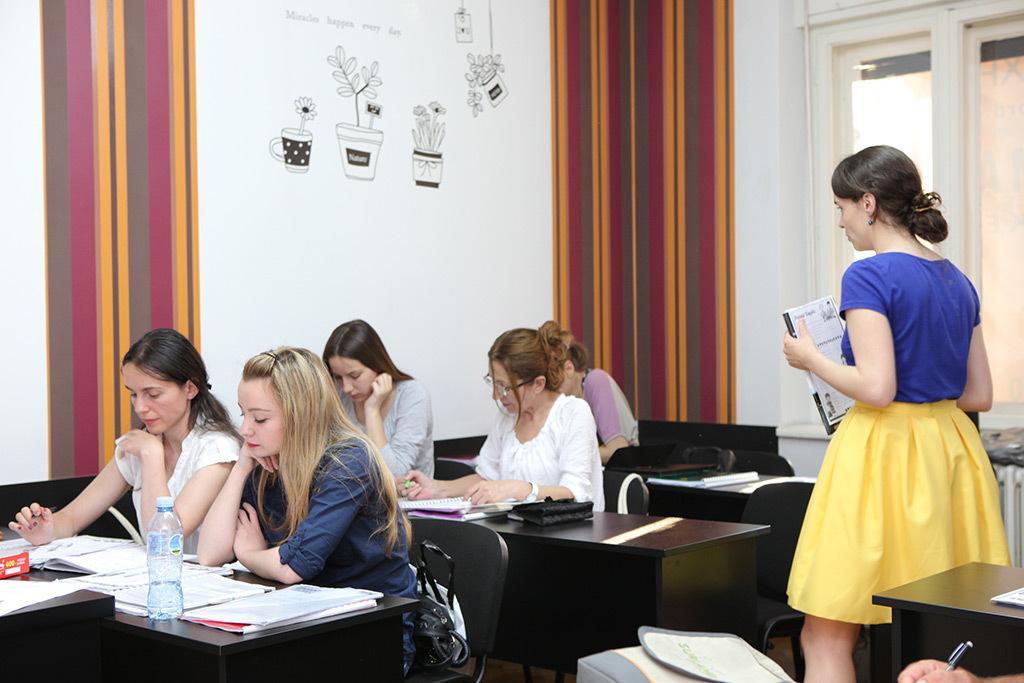Could you give a brief overview of what you see in this image? In this image I see 5 women who are sitting and there are tables in front of them and there are books on it. I can also see there is a woman over here and she is holding the book. In the background I see the wall, windows and art over here. 